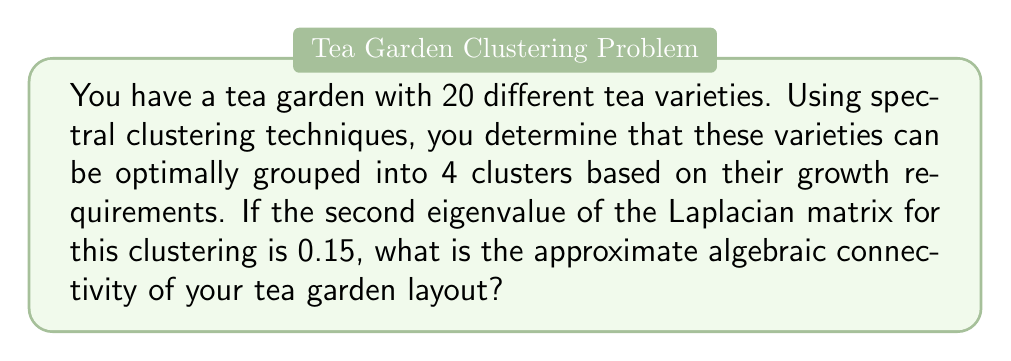Show me your answer to this math problem. To solve this problem, we need to understand the relationship between spectral clustering and the Laplacian matrix:

1. In spectral clustering, we use the eigenvalues of the Laplacian matrix to determine the optimal number of clusters.

2. The second smallest eigenvalue of the Laplacian matrix is known as the algebraic connectivity or Fiedler value.

3. For a graph with $n$ vertices (in this case, 20 tea varieties) clustered into $k$ groups (in this case, 4 clusters), the algebraic connectivity $\lambda_2$ is related to the second eigenvalue $\mu_2$ of the normalized Laplacian by the following approximation:

   $$\lambda_2 \approx \frac{n}{k} \mu_2$$

4. We are given that the second eigenvalue $\mu_2 = 0.15$.

5. Substituting the values into the formula:

   $$\lambda_2 \approx \frac{20}{4} \cdot 0.15 = 5 \cdot 0.15 = 0.75$$

Therefore, the approximate algebraic connectivity of the tea garden layout is 0.75.
Answer: 0.75 